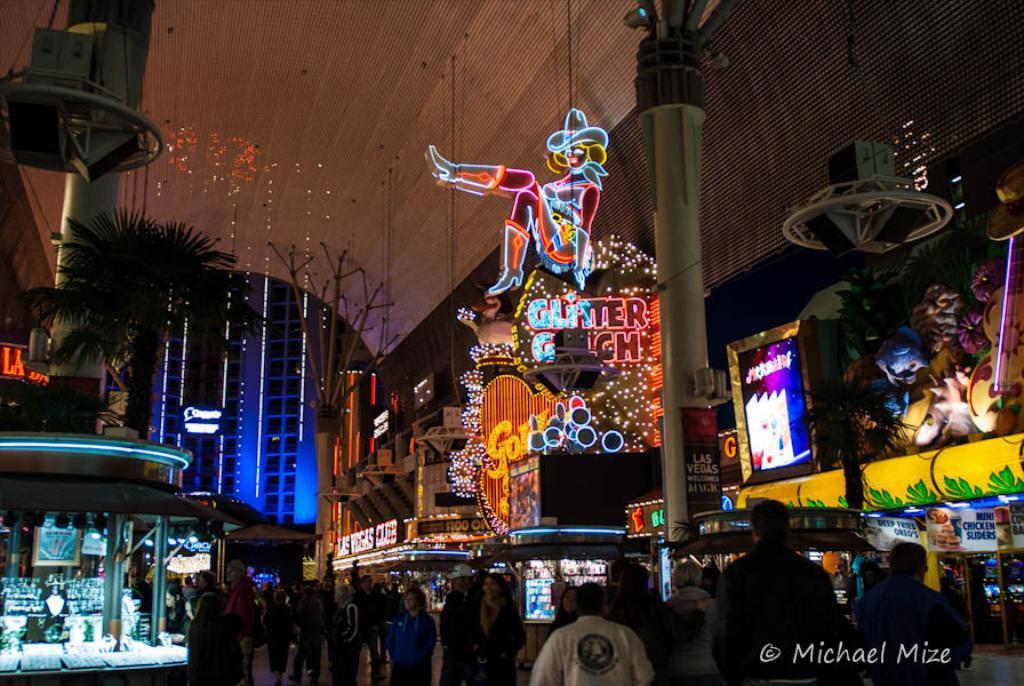Describe this image in one or two sentences. This image consists of many buildings along with the lights. At the top, there is a roof. In the front, we can see many people walking on the road. At the bottom, there are shops. On the left, we can see a tree. 